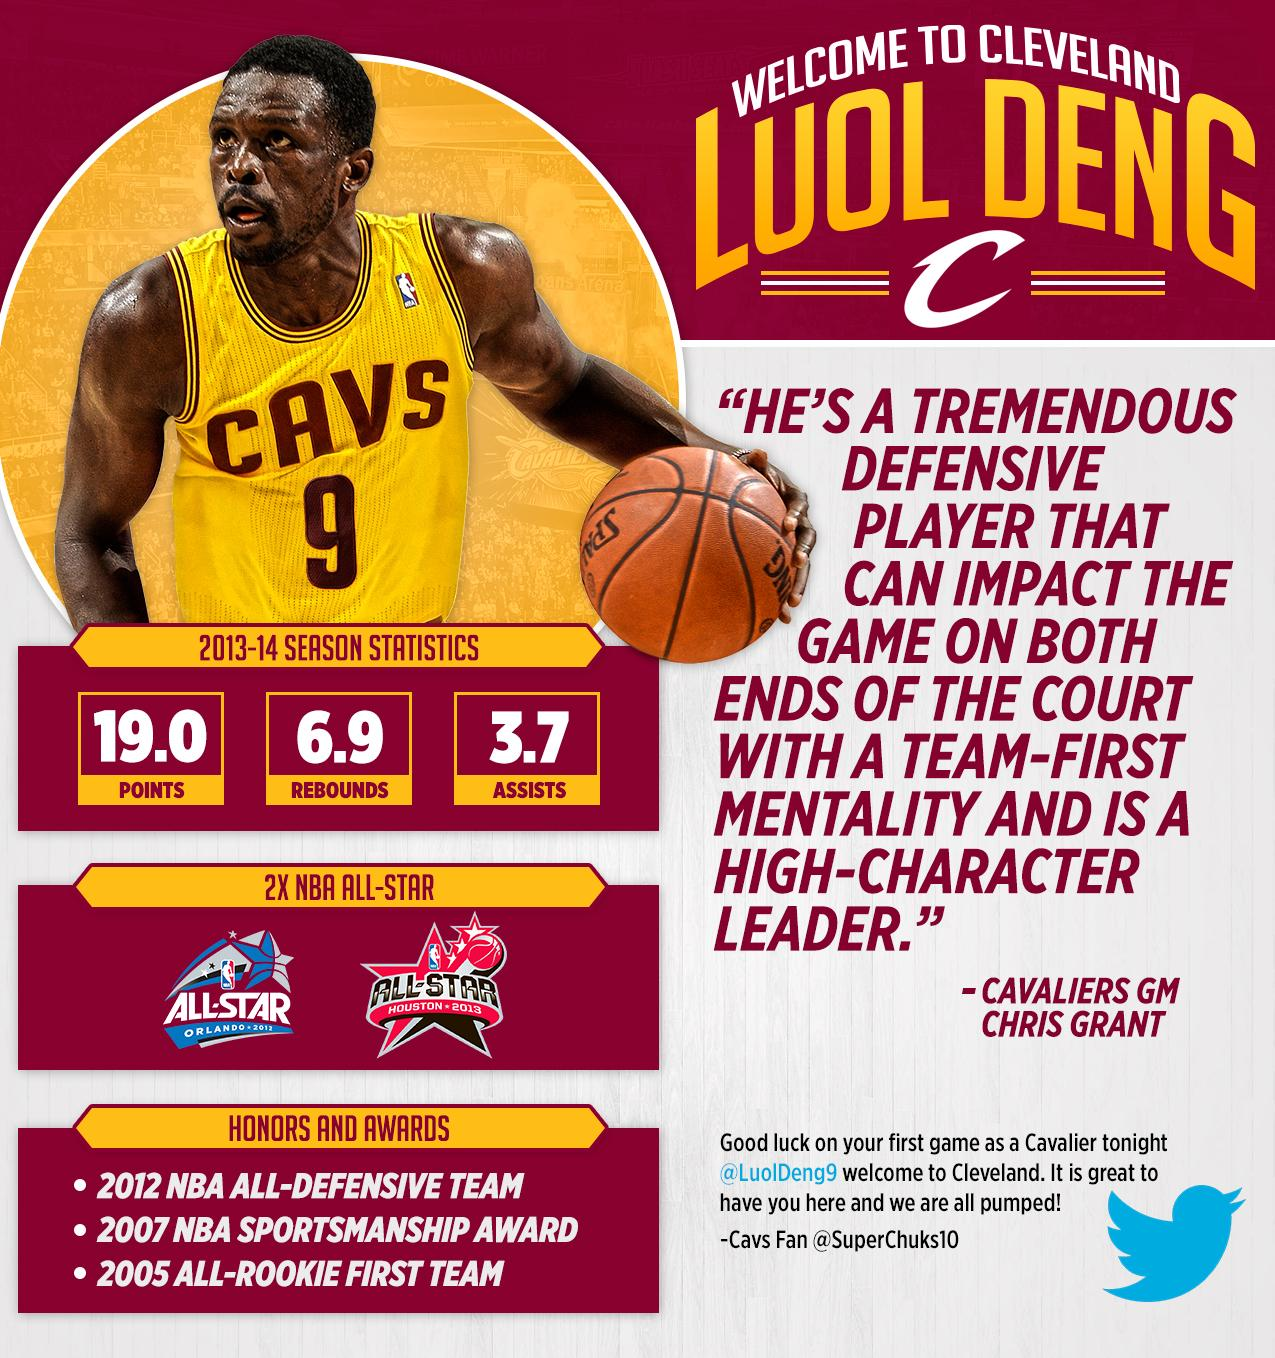Mention a couple of crucial points in this snapshot. Cleveland Cavaliers scored 19 points in the 2013-14 season. The Cleveland Cavaliers have received a total of three honors and awards. 